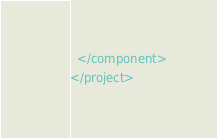<code> <loc_0><loc_0><loc_500><loc_500><_XML_>  </component>
</project></code> 